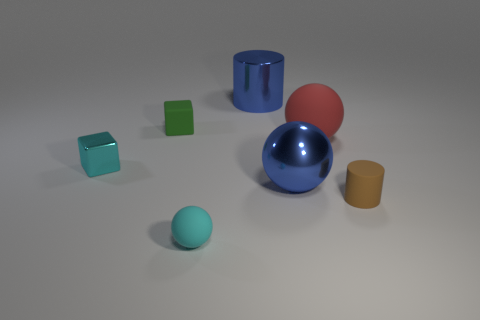What material is the sphere that is both to the right of the blue metallic cylinder and in front of the red rubber ball?
Keep it short and to the point. Metal. What number of objects are either small things behind the small brown rubber object or big shiny spheres?
Provide a short and direct response. 3. Do the large metallic sphere and the small metal thing have the same color?
Your answer should be compact. No. Are there any brown things of the same size as the green object?
Keep it short and to the point. Yes. What number of objects are right of the cyan block and on the left side of the tiny brown object?
Offer a terse response. 5. There is a small green rubber cube; how many tiny matte cubes are left of it?
Your answer should be very brief. 0. Is there another green rubber thing of the same shape as the large matte thing?
Your answer should be very brief. No. Is the shape of the small cyan matte thing the same as the small rubber thing that is behind the brown matte cylinder?
Your answer should be very brief. No. What number of cubes are large green things or small cyan objects?
Keep it short and to the point. 1. What shape is the big blue object behind the big red thing?
Make the answer very short. Cylinder. 